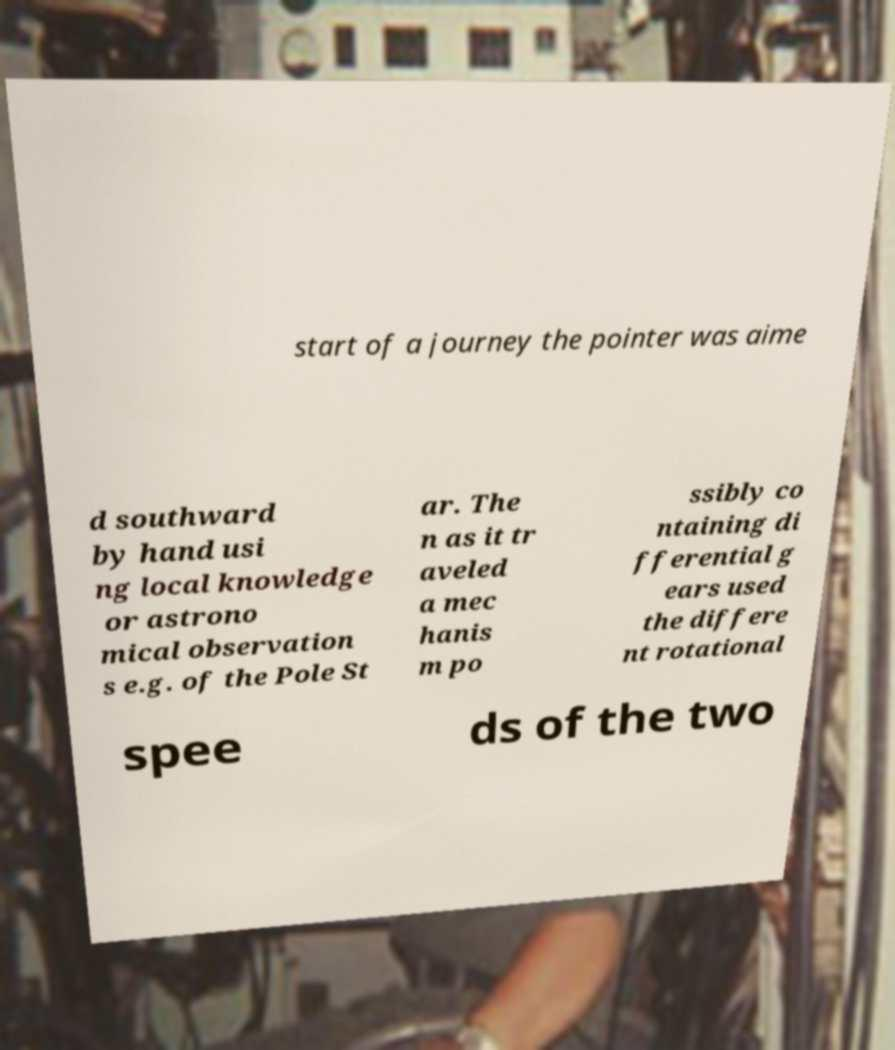I need the written content from this picture converted into text. Can you do that? start of a journey the pointer was aime d southward by hand usi ng local knowledge or astrono mical observation s e.g. of the Pole St ar. The n as it tr aveled a mec hanis m po ssibly co ntaining di fferential g ears used the differe nt rotational spee ds of the two 